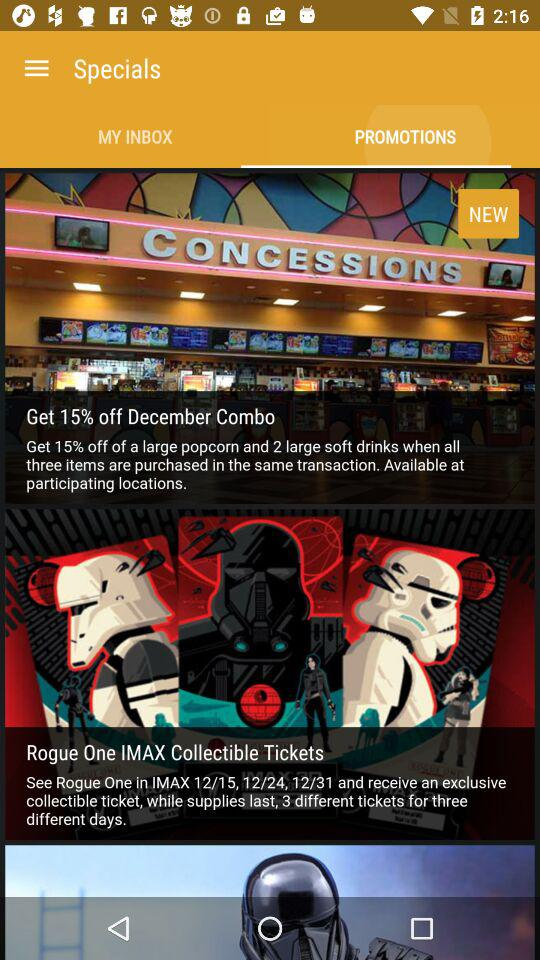How much discount is available in the "December Combo"? The available discount in the "December Combo" is 15%. 